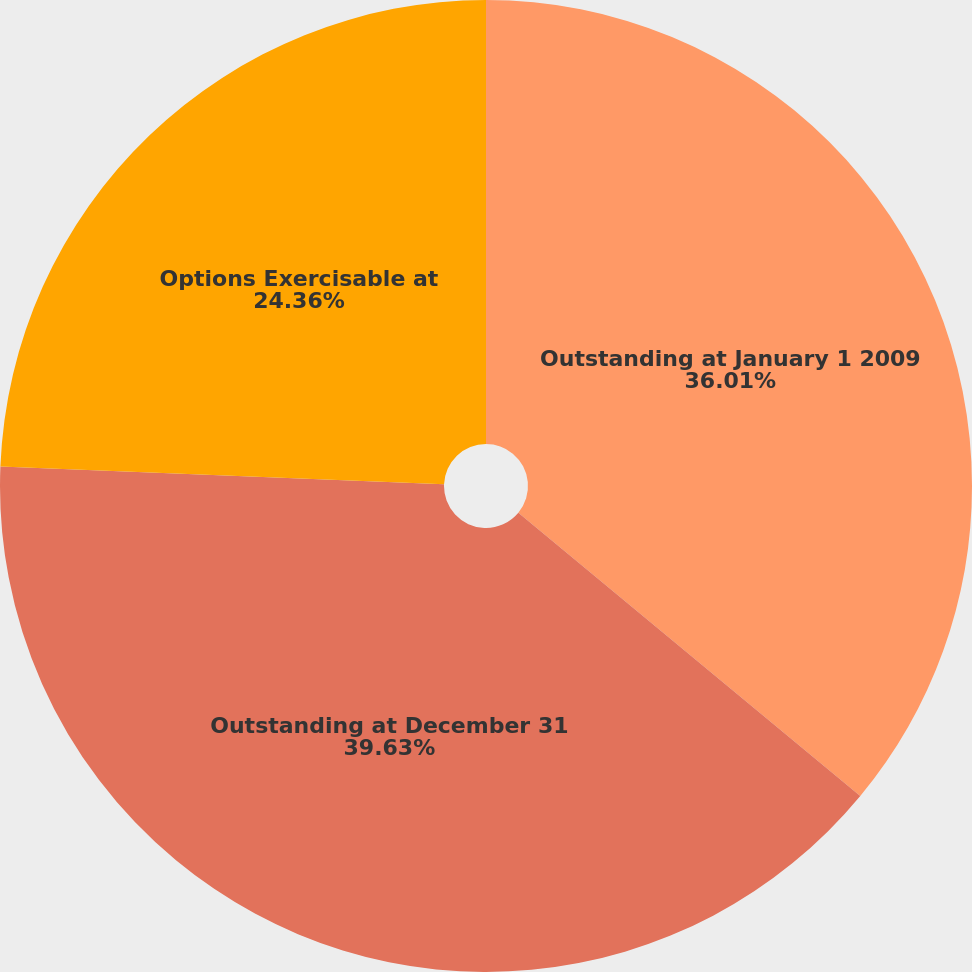Convert chart to OTSL. <chart><loc_0><loc_0><loc_500><loc_500><pie_chart><fcel>Outstanding at January 1 2009<fcel>Outstanding at December 31<fcel>Options Exercisable at<nl><fcel>36.01%<fcel>39.63%<fcel>24.36%<nl></chart> 